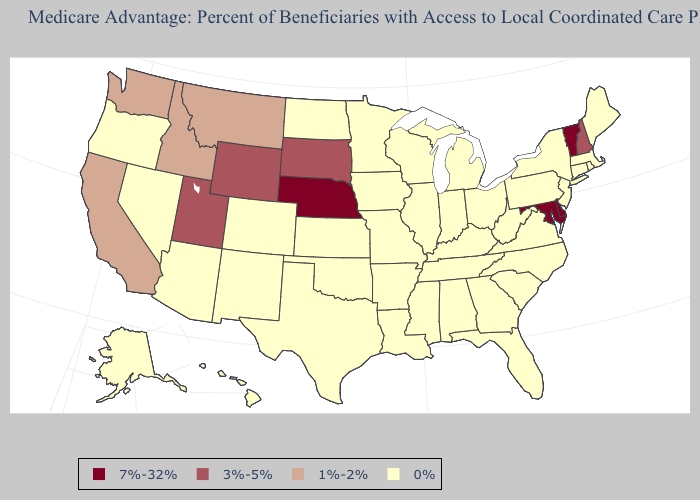Does Illinois have the highest value in the MidWest?
Short answer required. No. Among the states that border South Carolina , which have the highest value?
Keep it brief. Georgia, North Carolina. Name the states that have a value in the range 3%-5%?
Short answer required. New Hampshire, South Dakota, Utah, Wyoming. What is the highest value in the Northeast ?
Quick response, please. 7%-32%. What is the value of Arizona?
Answer briefly. 0%. Among the states that border Connecticut , which have the highest value?
Short answer required. Massachusetts, New York, Rhode Island. What is the value of South Dakota?
Short answer required. 3%-5%. Name the states that have a value in the range 3%-5%?
Quick response, please. New Hampshire, South Dakota, Utah, Wyoming. What is the highest value in the USA?
Keep it brief. 7%-32%. How many symbols are there in the legend?
Be succinct. 4. What is the value of New Mexico?
Concise answer only. 0%. What is the highest value in the Northeast ?
Concise answer only. 7%-32%. Does Florida have the lowest value in the USA?
Give a very brief answer. Yes. How many symbols are there in the legend?
Write a very short answer. 4. 